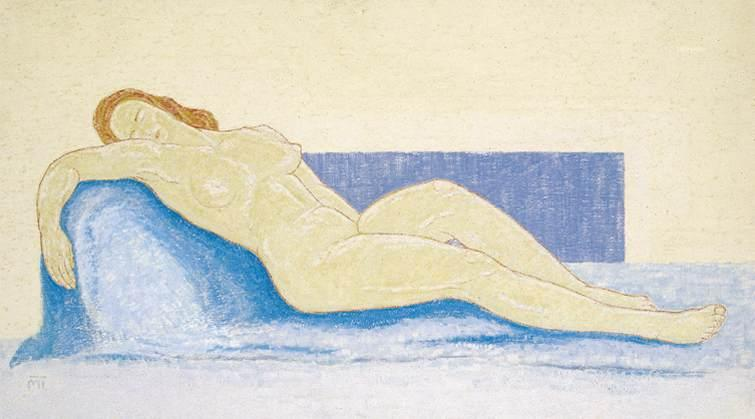Write a detailed description of the given image. The image is a striking example of an impressionistic pastel artwork depicting a nude woman reclining on a blue couch. She rests her head on her extended arm, embodying a sense of deep relaxation or introspection. The soft pastel tones perfectly capture the smooth curves of her form against the contrasting sharp blue of the couch. The background, a pale yellow, emphasizes a serene and subdued atmosphere, highlighting the tranquility of the scene. This artwork, while primarily showcasing an individual in a moment of repose, also subtly invokes themes of vulnerability and peace through its gentle color palette and the relaxed posture of the figure. 